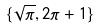<formula> <loc_0><loc_0><loc_500><loc_500>\{ \sqrt { \pi } , 2 \pi + 1 \}</formula> 